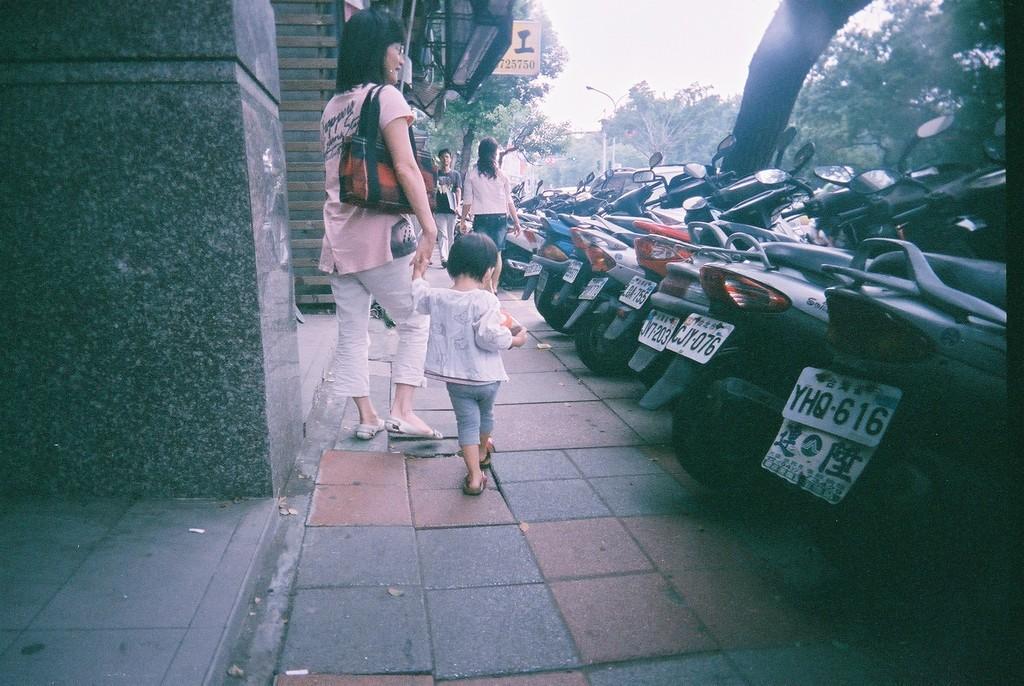In one or two sentences, can you explain what this image depicts? In the picture I can see people standing on the ground. In the background I can see vehicles, trees, street lights, sign board, trees, the sky and some other objects on the ground. 